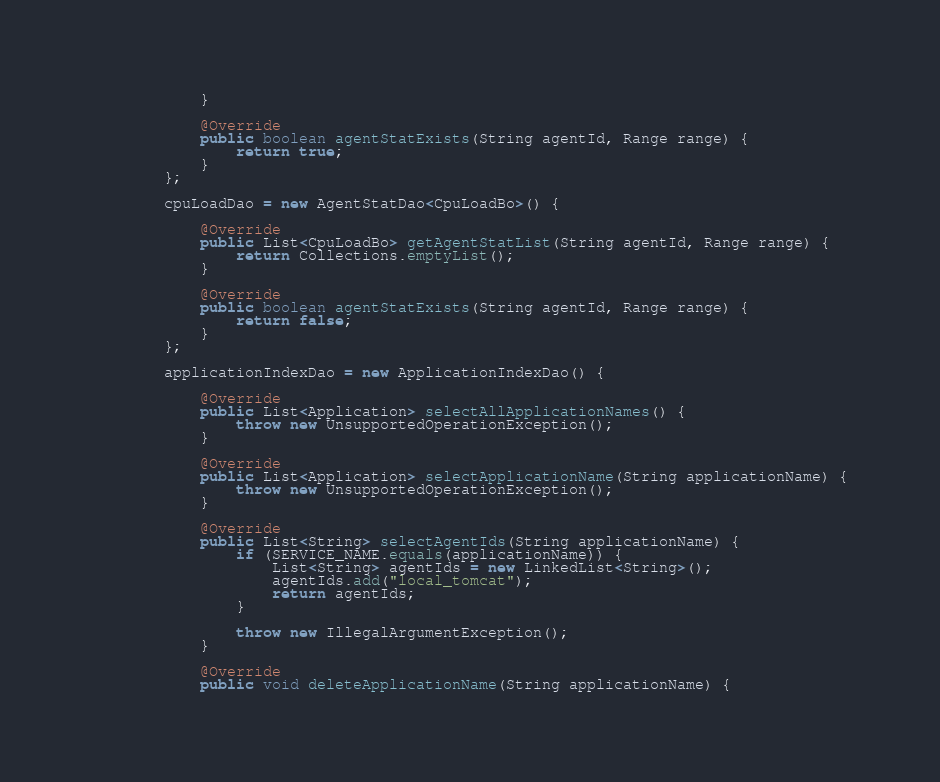Convert code to text. <code><loc_0><loc_0><loc_500><loc_500><_Java_>            }

            @Override
            public boolean agentStatExists(String agentId, Range range) {
                return true;
            }
        };

        cpuLoadDao = new AgentStatDao<CpuLoadBo>() {

            @Override
            public List<CpuLoadBo> getAgentStatList(String agentId, Range range) {
                return Collections.emptyList();
            }

            @Override
            public boolean agentStatExists(String agentId, Range range) {
                return false;
            }
        };

        applicationIndexDao = new ApplicationIndexDao() {

            @Override
            public List<Application> selectAllApplicationNames() {
                throw new UnsupportedOperationException();
            }

            @Override
            public List<Application> selectApplicationName(String applicationName) {
                throw new UnsupportedOperationException();
            }

            @Override
            public List<String> selectAgentIds(String applicationName) {
                if (SERVICE_NAME.equals(applicationName)) {
                    List<String> agentIds = new LinkedList<String>();
                    agentIds.add("local_tomcat");
                    return agentIds;
                }

                throw new IllegalArgumentException();
            }

            @Override
            public void deleteApplicationName(String applicationName) {</code> 